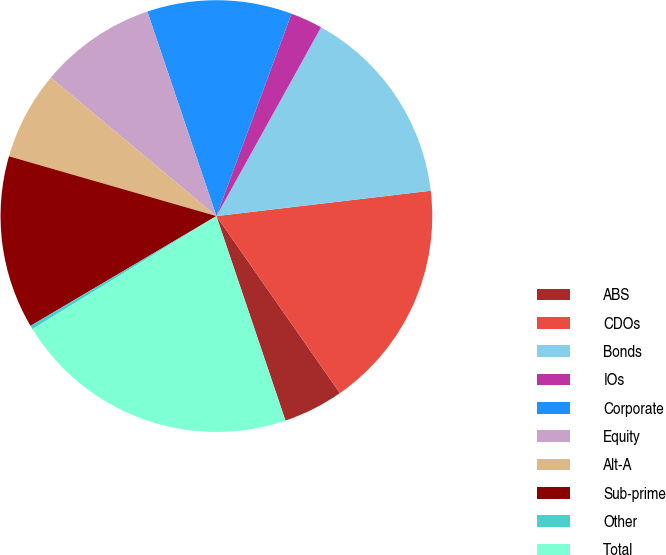Convert chart. <chart><loc_0><loc_0><loc_500><loc_500><pie_chart><fcel>ABS<fcel>CDOs<fcel>Bonds<fcel>IOs<fcel>Corporate<fcel>Equity<fcel>Alt-A<fcel>Sub-prime<fcel>Other<fcel>Total<nl><fcel>4.51%<fcel>17.18%<fcel>15.07%<fcel>2.4%<fcel>10.84%<fcel>8.73%<fcel>6.62%<fcel>12.96%<fcel>0.28%<fcel>21.41%<nl></chart> 